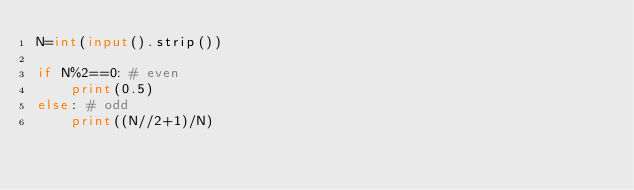Convert code to text. <code><loc_0><loc_0><loc_500><loc_500><_Python_>N=int(input().strip())

if N%2==0: # even
    print(0.5)
else: # odd
    print((N//2+1)/N)</code> 